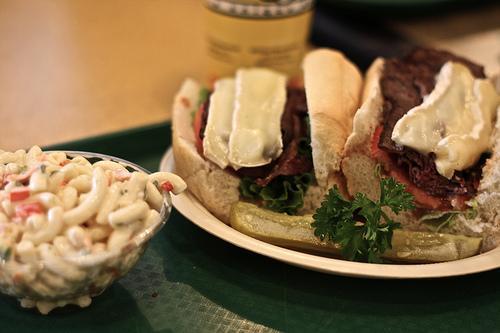How many cups are there?
Give a very brief answer. 1. How many bowls are there?
Give a very brief answer. 1. How many plates are there?
Give a very brief answer. 1. 